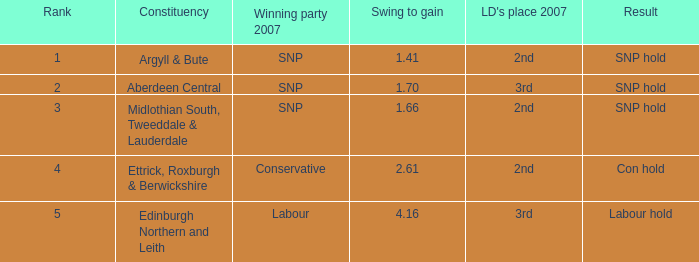16, the victorious party in 2007 is snp, and ld's position in 2007 is runner-up? Argyll & Bute, Midlothian South, Tweeddale & Lauderdale. Would you be able to parse every entry in this table? {'header': ['Rank', 'Constituency', 'Winning party 2007', 'Swing to gain', "LD's place 2007", 'Result'], 'rows': [['1', 'Argyll & Bute', 'SNP', '1.41', '2nd', 'SNP hold'], ['2', 'Aberdeen Central', 'SNP', '1.70', '3rd', 'SNP hold'], ['3', 'Midlothian South, Tweeddale & Lauderdale', 'SNP', '1.66', '2nd', 'SNP hold'], ['4', 'Ettrick, Roxburgh & Berwickshire', 'Conservative', '2.61', '2nd', 'Con hold'], ['5', 'Edinburgh Northern and Leith', 'Labour', '4.16', '3rd', 'Labour hold']]} 